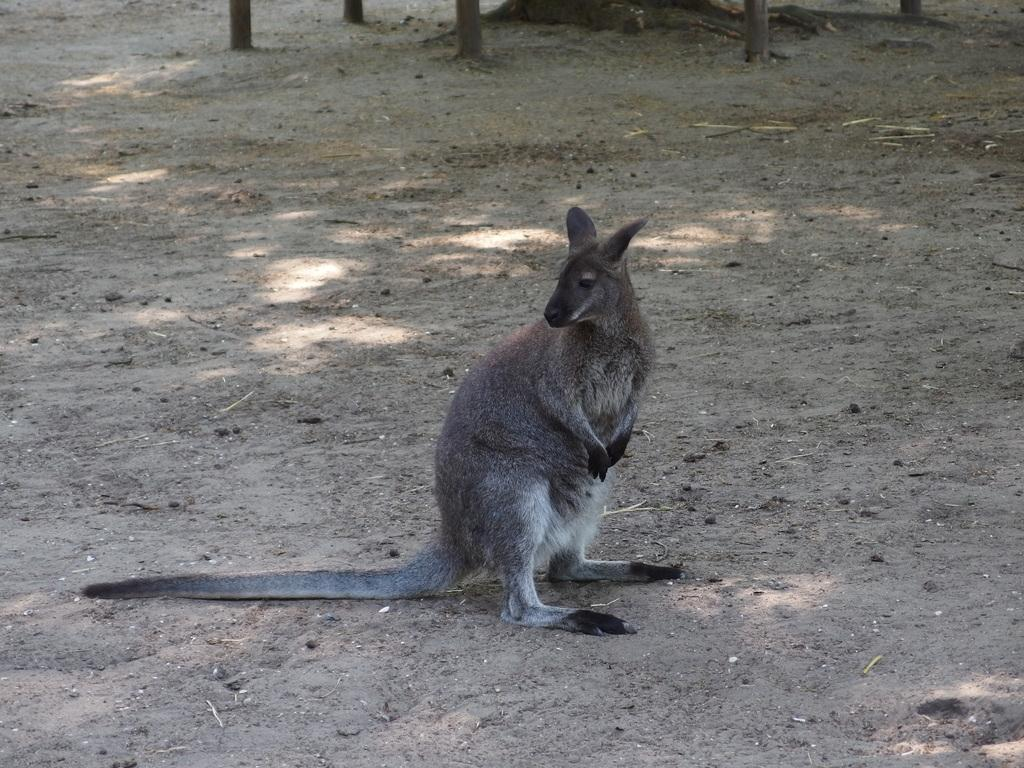What type of animal is in the image? There is a kangaroo in the image. Where is the kangaroo located in the image? The kangaroo is on the ground. How many feet does the kangaroo have in the image? The number of feet the kangaroo has cannot be determined from the image alone. What is the price of the kangaroo in the image? There is no indication of a price for the kangaroo in the image. 